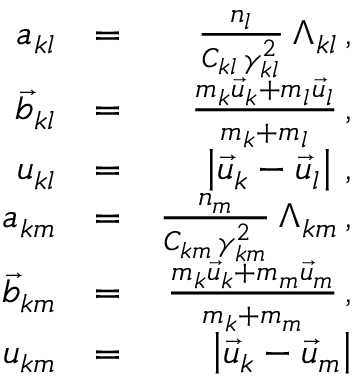Convert formula to latex. <formula><loc_0><loc_0><loc_500><loc_500>\begin{array} { r l r } { a _ { k l } } & { = } & { \frac { n _ { l } } { C _ { k l } \, \gamma _ { k l } ^ { 2 } } \, \Lambda _ { k l } \, , } \\ { \vec { b } _ { k l } } & { = } & { \frac { m _ { k } \vec { u } _ { k } + m _ { l } \vec { u } _ { l } } { m _ { k } + m _ { l } } \, , } \\ { u _ { k l } } & { = } & { \left | \vec { u } _ { k } - \vec { u } _ { l } \right | \, , } \\ { a _ { k m } } & { = } & { \frac { n _ { m } } { C _ { k m } \, \gamma _ { k m } ^ { 2 } } \, \Lambda _ { k m } \, , } \\ { \vec { b } _ { k m } } & { = } & { \frac { m _ { k } \vec { u } _ { k } + m _ { m } \vec { u } _ { m } } { m _ { k } + m _ { m } } \, , } \\ { u _ { k m } } & { = } & { \left | \vec { u } _ { k } - \vec { u } _ { m } \right | } \end{array}</formula> 